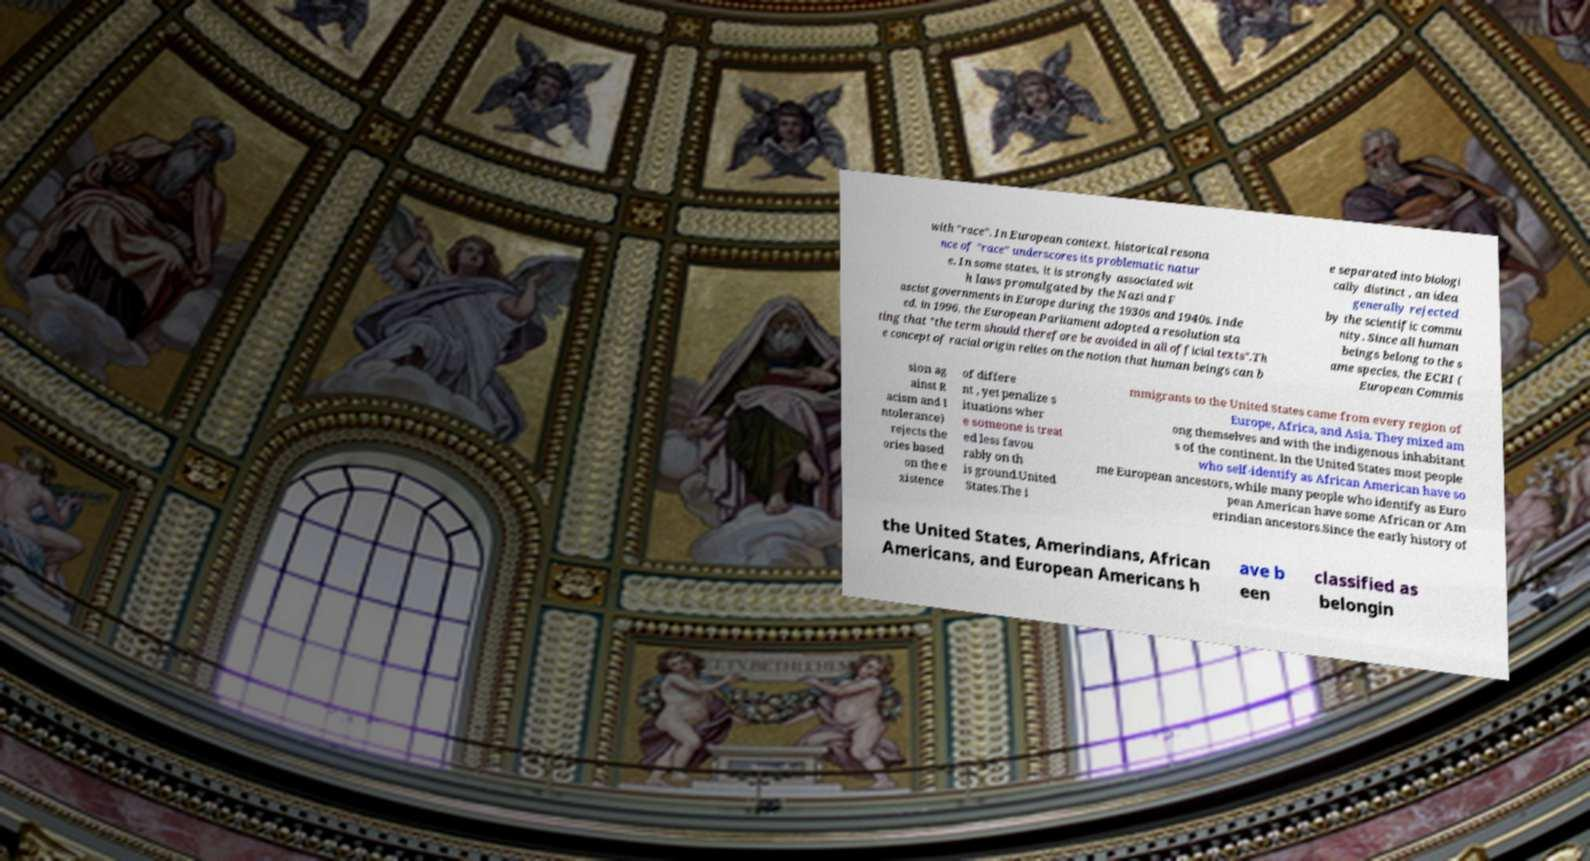Could you extract and type out the text from this image? with "race". In European context, historical resona nce of "race" underscores its problematic natur e. In some states, it is strongly associated wit h laws promulgated by the Nazi and F ascist governments in Europe during the 1930s and 1940s. Inde ed, in 1996, the European Parliament adopted a resolution sta ting that "the term should therefore be avoided in all official texts".Th e concept of racial origin relies on the notion that human beings can b e separated into biologi cally distinct , an idea generally rejected by the scientific commu nity. Since all human beings belong to the s ame species, the ECRI ( European Commis sion ag ainst R acism and I ntolerance) rejects the ories based on the e xistence of differe nt , yet penalize s ituations wher e someone is treat ed less favou rably on th is ground.United States.The i mmigrants to the United States came from every region of Europe, Africa, and Asia. They mixed am ong themselves and with the indigenous inhabitant s of the continent. In the United States most people who self-identify as African American have so me European ancestors, while many people who identify as Euro pean American have some African or Am erindian ancestors.Since the early history of the United States, Amerindians, African Americans, and European Americans h ave b een classified as belongin 